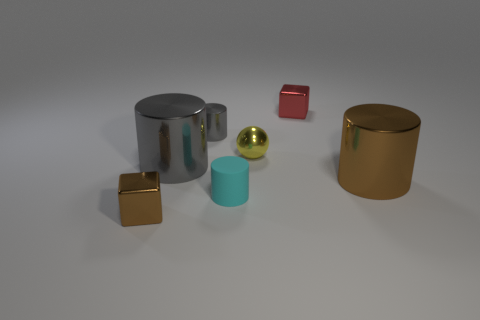Add 1 big cyan metallic blocks. How many objects exist? 8 Subtract all cylinders. How many objects are left? 3 Add 7 cyan things. How many cyan things are left? 8 Add 6 big green spheres. How many big green spheres exist? 6 Subtract 0 gray blocks. How many objects are left? 7 Subtract all tiny brown cubes. Subtract all tiny cubes. How many objects are left? 4 